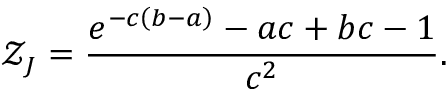<formula> <loc_0><loc_0><loc_500><loc_500>\mathcal { Z } _ { J } = \frac { e ^ { - c \left ( b - a \right ) } - a c + b c - 1 } { c ^ { 2 } } .</formula> 